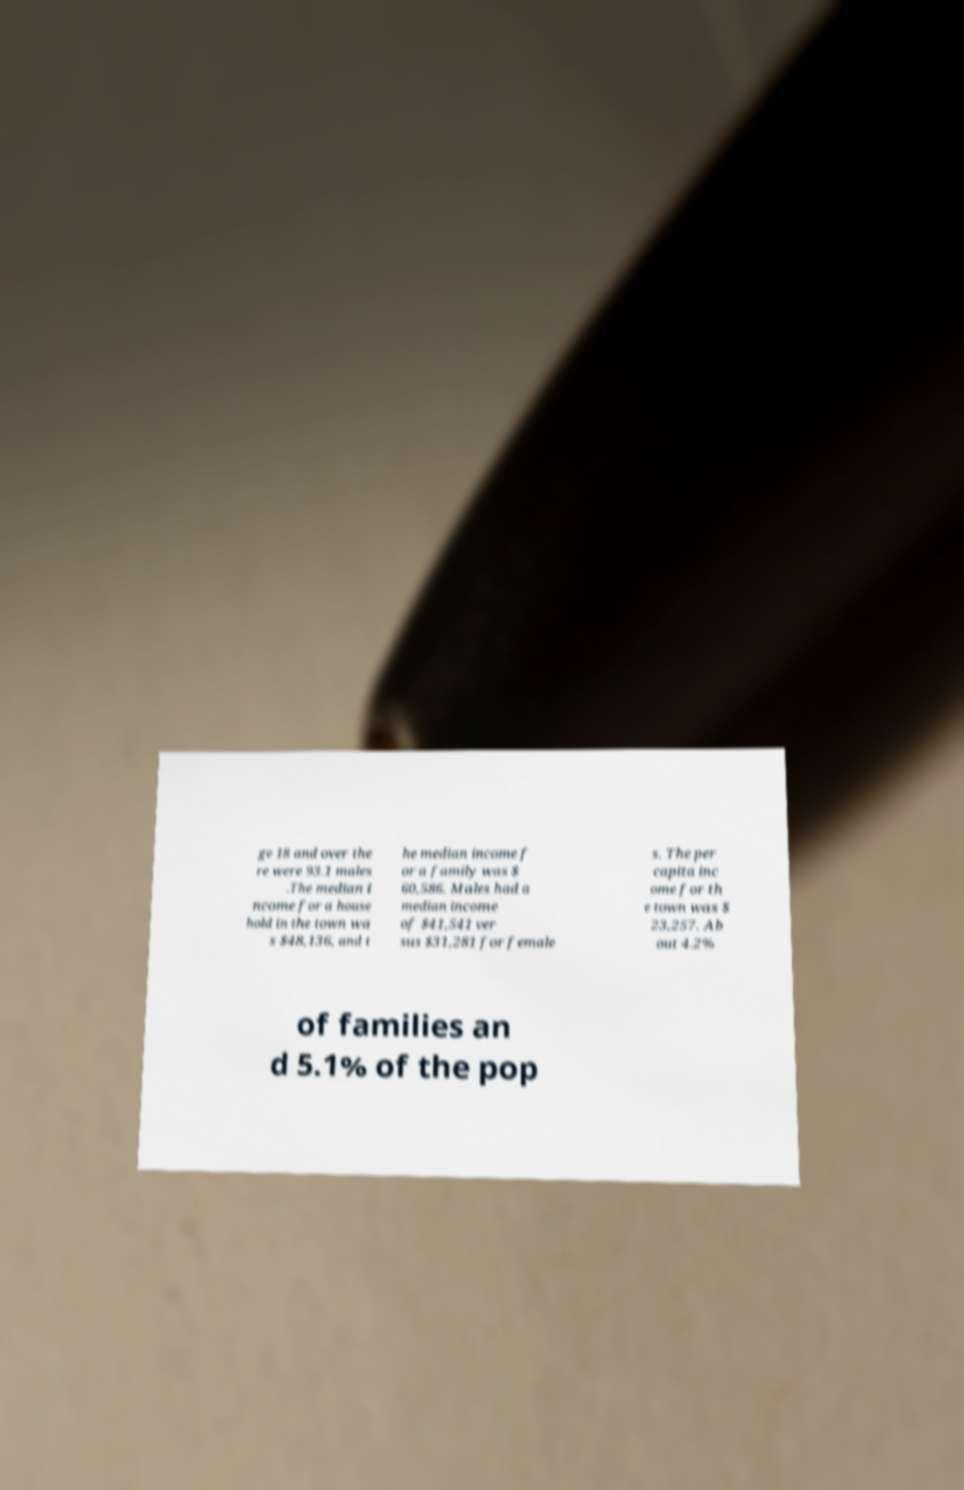Could you assist in decoding the text presented in this image and type it out clearly? ge 18 and over the re were 93.1 males .The median i ncome for a house hold in the town wa s $48,136, and t he median income f or a family was $ 60,586. Males had a median income of $41,541 ver sus $31,281 for female s. The per capita inc ome for th e town was $ 23,257. Ab out 4.2% of families an d 5.1% of the pop 